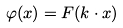Convert formula to latex. <formula><loc_0><loc_0><loc_500><loc_500>\varphi ( x ) = F ( k \cdot x )</formula> 